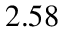Convert formula to latex. <formula><loc_0><loc_0><loc_500><loc_500>2 . 5 8</formula> 